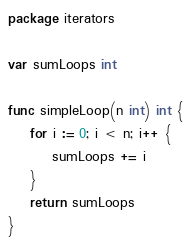<code> <loc_0><loc_0><loc_500><loc_500><_Go_>package iterators

var sumLoops int

func simpleLoop(n int) int {
	for i := 0; i < n; i++ {
		sumLoops += i
	}
	return sumLoops
}
</code> 